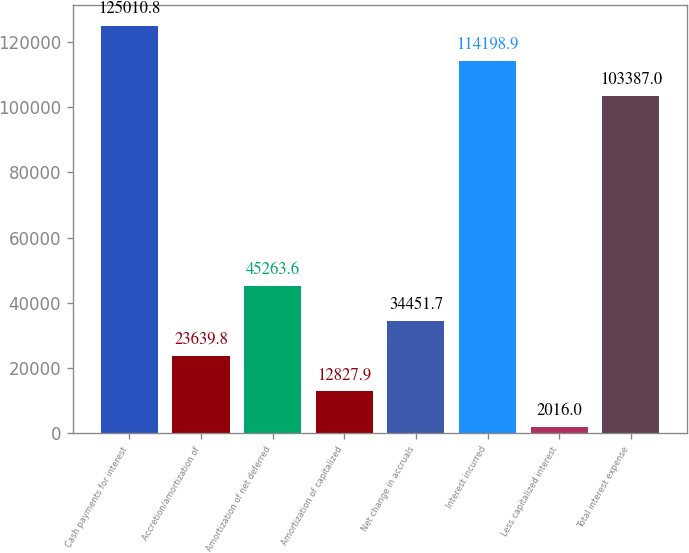Convert chart. <chart><loc_0><loc_0><loc_500><loc_500><bar_chart><fcel>Cash payments for interest<fcel>Accretion/amortization of<fcel>Amortization of net deferred<fcel>Amortization of capitalized<fcel>Net change in accruals<fcel>Interest incurred<fcel>Less capitalized interest<fcel>Total interest expense<nl><fcel>125011<fcel>23639.8<fcel>45263.6<fcel>12827.9<fcel>34451.7<fcel>114199<fcel>2016<fcel>103387<nl></chart> 